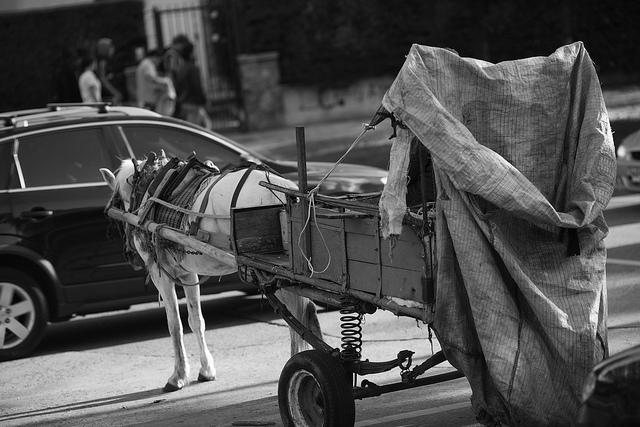Why is the animal that is hooked up to the cart doing? waiting 